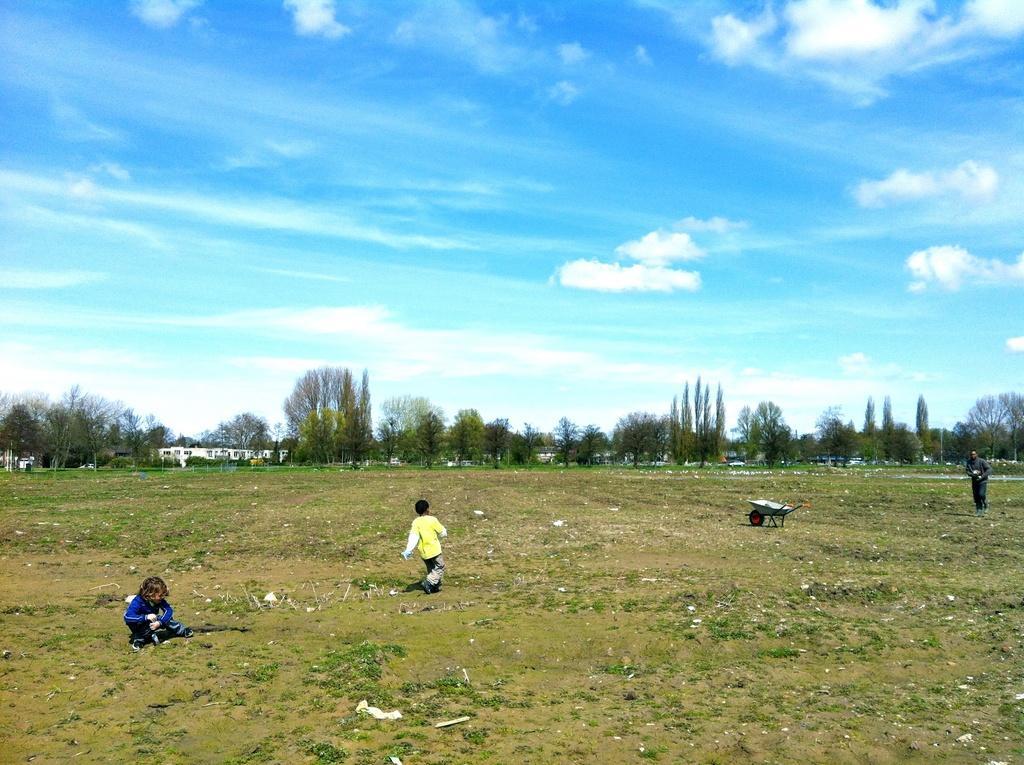Could you give a brief overview of what you see in this image? In this image I can see an open grass ground and on it I can see two children and one person. I can also see a trolley on the right side. In the background I can see number of trees, few buildings, clouds and the sky. 